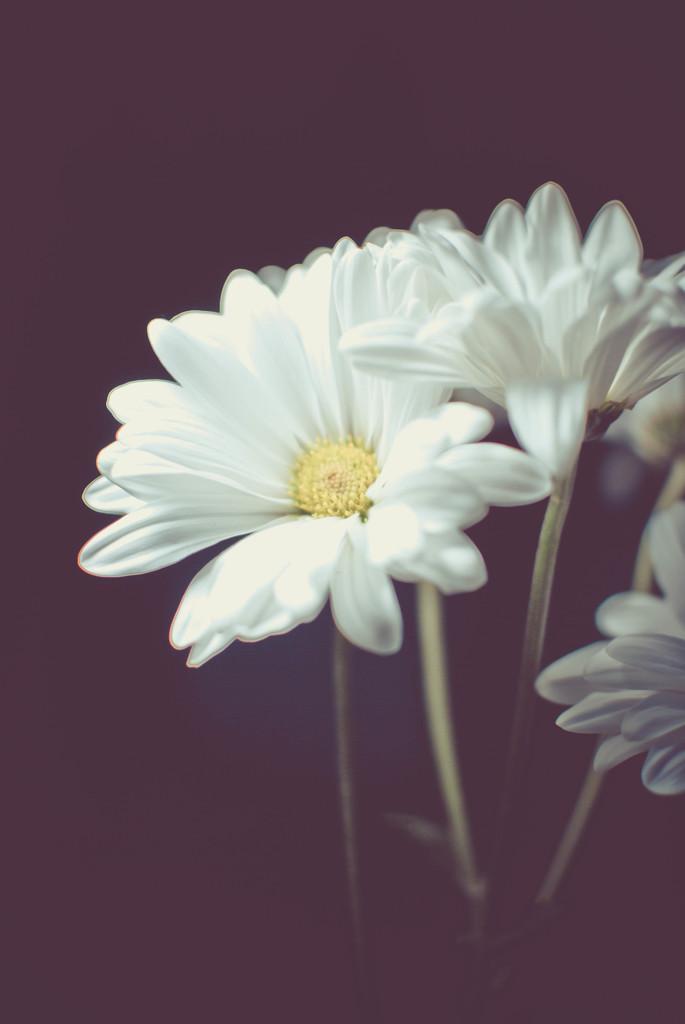Describe this image in one or two sentences. In this image I can see few flowers which are white and yellow in color and the black colored background. 